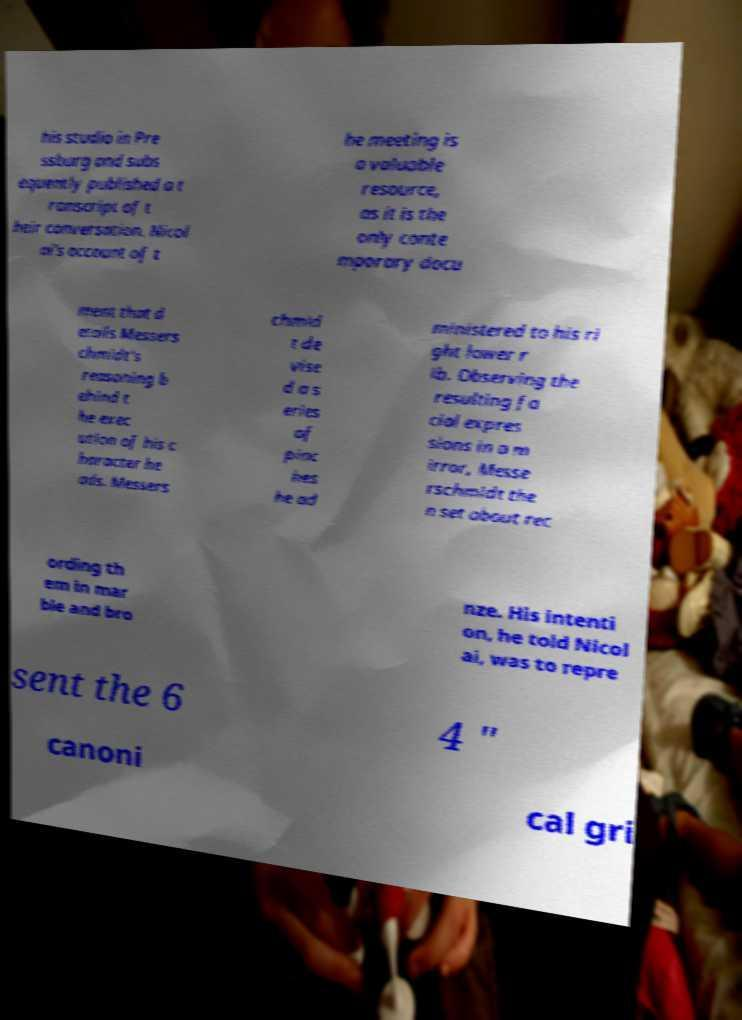For documentation purposes, I need the text within this image transcribed. Could you provide that? his studio in Pre ssburg and subs equently published a t ranscript of t heir conversation. Nicol ai's account of t he meeting is a valuable resource, as it is the only conte mporary docu ment that d etails Messers chmidt's reasoning b ehind t he exec ution of his c haracter he ads. Messers chmid t de vise d a s eries of pinc hes he ad ministered to his ri ght lower r ib. Observing the resulting fa cial expres sions in a m irror, Messe rschmidt the n set about rec ording th em in mar ble and bro nze. His intenti on, he told Nicol ai, was to repre sent the 6 4 " canoni cal gri 